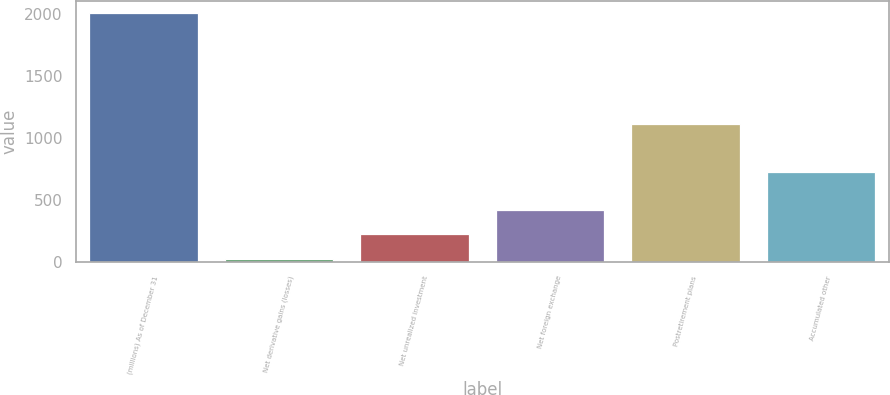Convert chart. <chart><loc_0><loc_0><loc_500><loc_500><bar_chart><fcel>(millions) As of December 31<fcel>Net derivative gains (losses)<fcel>Net unrealized investment<fcel>Net foreign exchange<fcel>Postretirement plans<fcel>Accumulated other<nl><fcel>2007<fcel>24<fcel>222.3<fcel>420.6<fcel>1110<fcel>726<nl></chart> 